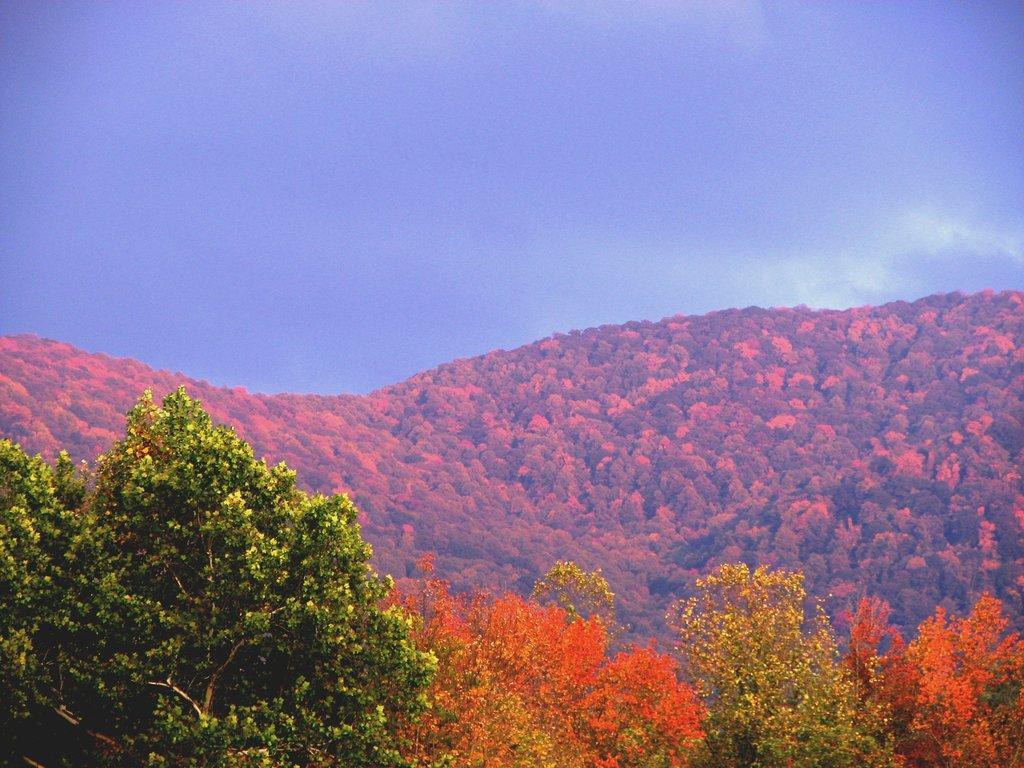Can you describe this image briefly? In this picture we can see trees, mountains and in the background we can see the sky with clouds. 